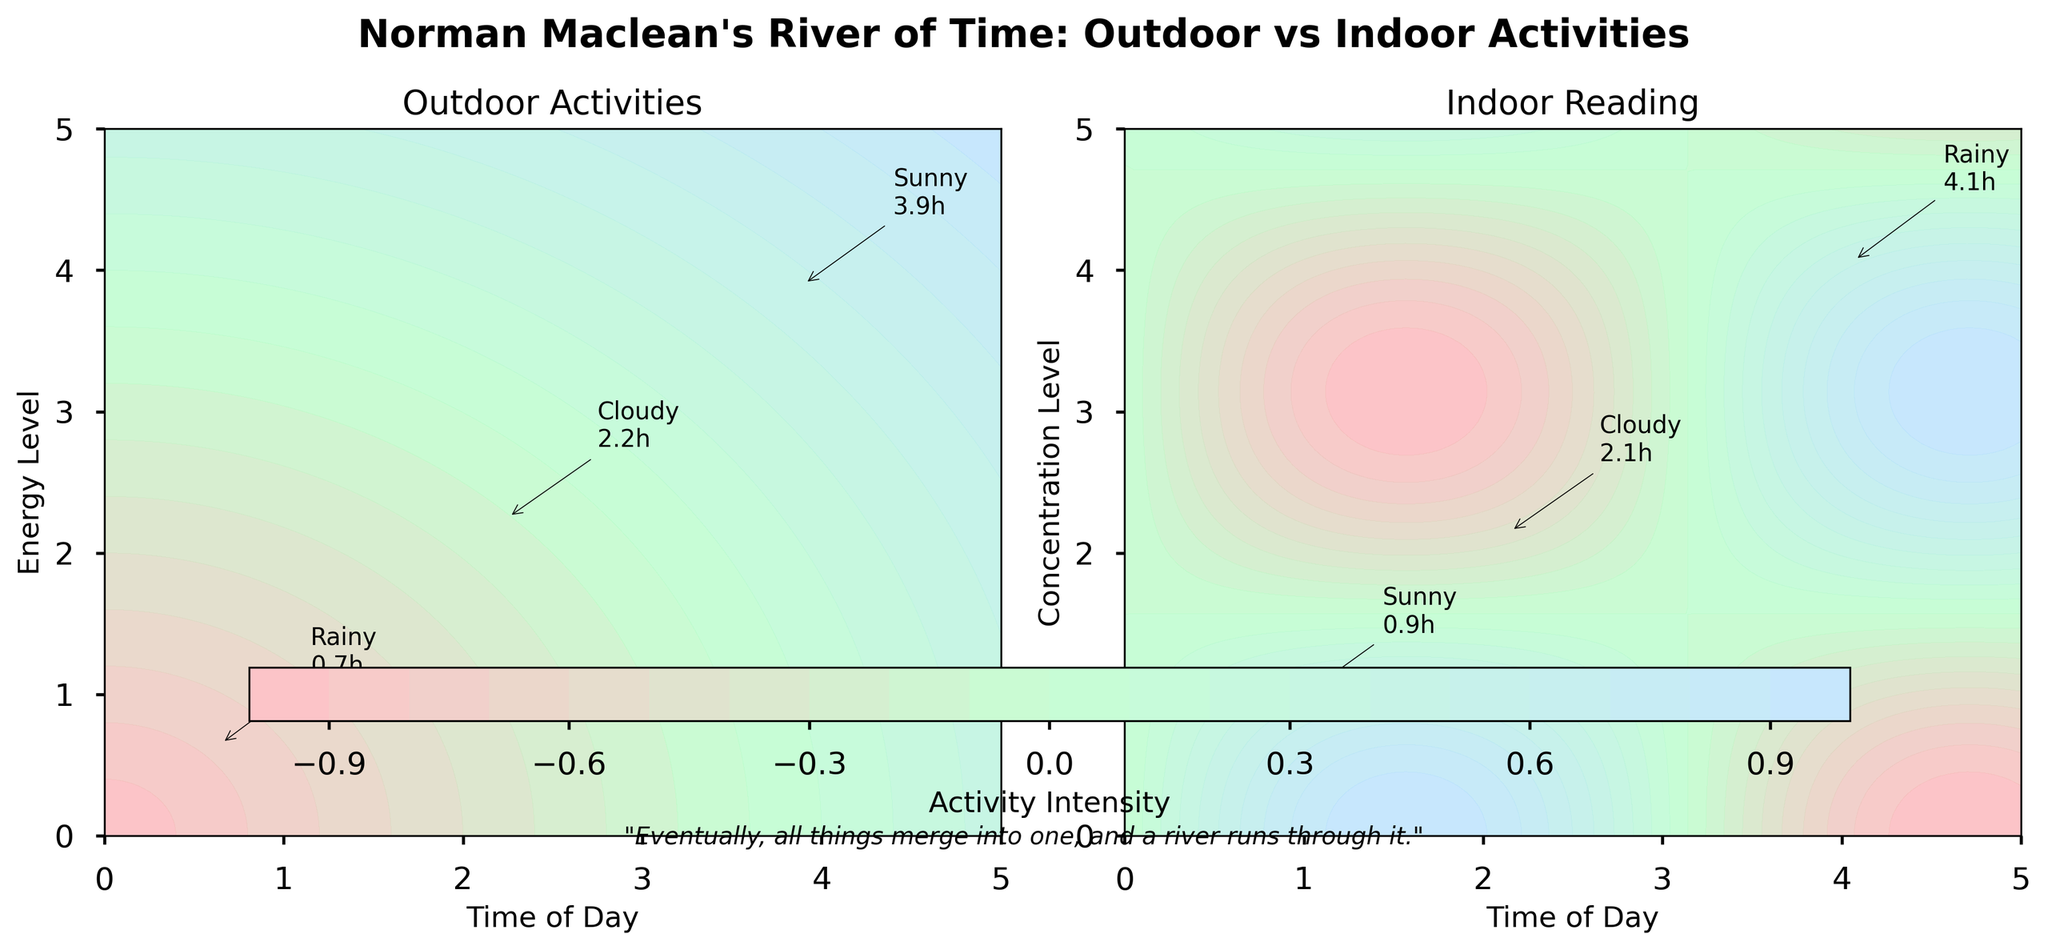How are the axes labeled for the plot titled 'Outdoor Activities'? The outdoor activities plot has the x-axis labeled 'Time of Day' and the y-axis labeled 'Energy Level'.
Answer: 'Time of Day' and 'Energy Level' How long do people on average spend on outdoor activities on sunny days? The annotations in the outdoor activities plot show that on sunny days, people spend an average of 3.97 hours on outdoor activities.
Answer: 3.97 hours Which weather condition has the highest average time spent on indoor reading? Annotations in the indoor reading plot show that the rainy condition has the highest average time spent on indoor reading, which is 4.1 hours.
Answer: Rainy How does the visual appearance of the 'Indoor Reading' plot differ from the 'Outdoor Activities' plot? In the 'Indoor Reading' plot, the contour patterns are influenced by the sine and cosine functions, creating a wave-like design. In contrast, the 'Outdoor Activities' plot shows circular gradient patterns.
Answer: Wave-like vs Circular Compare the average time spent on indoor reading on cloudy days versus sunny days. The indoor reading plot annotations show that the average time spent on indoor reading is 2.15 hours on cloudy days and 0.97 hours on sunny days. 2.15 is significantly higher than 0.97.
Answer: Cloudy days: 2.15 hours, Sunny days: 0.97 hours Which subplot features annotations indicating time spent? Both subplots, 'Outdoor Activities' and 'Indoor Reading,' feature annotations indicating the average time spent under different weather conditions.
Answer: Both What range of colors does the customized colormap use? The customized colormap uses a gradient of colors ranging from shades of pink, green, to light blue.
Answer: Pink to green to light blue What is the quote included in the figure? The quote included in the figure is: "Eventually, all things merge into one, and a river runs through it."
Answer: "Eventually, all things merge into one, and a river runs through it." How does the average time spent on outdoor activities vary between sunny and rainy conditions? The 'Outdoor Activities' plot annotations reveal that people spend an average of 3.97 hours on sunny days, compared to only 0.65 hours on rainy days, showing a significant decrease when it is rainy.
Answer: Sunny: 3.97 hours, Rainy: 0.65 hours What annotation details can be found near the highest peak in the 'Indoor Reading' plot? Near the highest peak in the 'Indoor Reading' plot, the annotation indicates that during rainy weather, the average time spent on indoor reading is 4.1 hours.
Answer: Rainy: 4.1 hours 